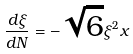<formula> <loc_0><loc_0><loc_500><loc_500>\frac { d \xi } { d N } = - \sqrt { 6 } \xi ^ { 2 } x</formula> 